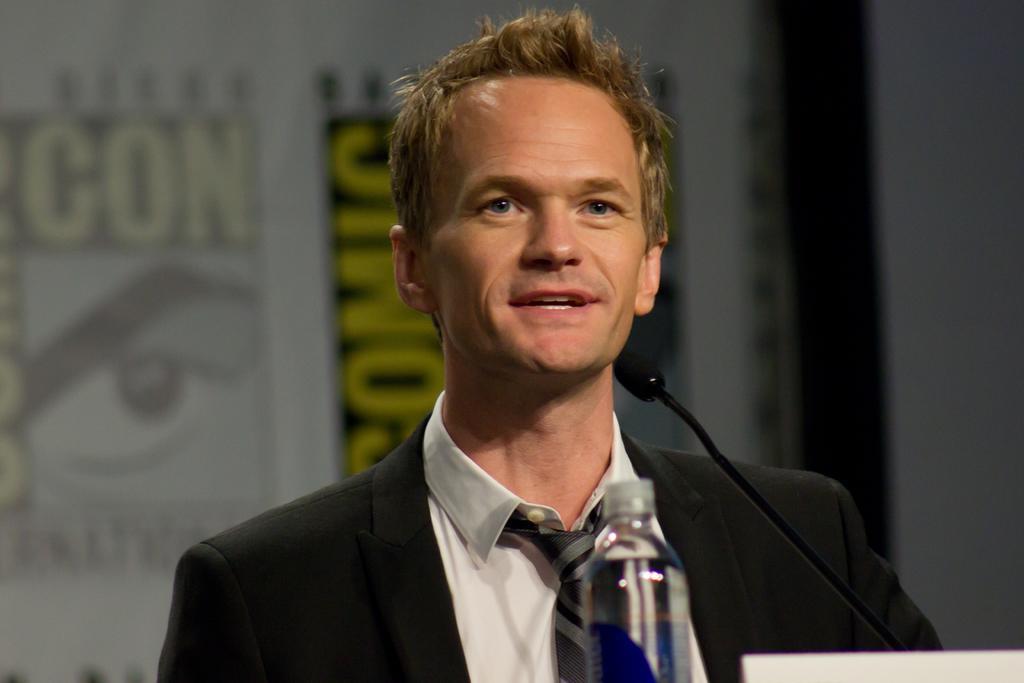Can you describe this image briefly? In this picture there is a man standing and speaking, he has a microphone and a water bottle in front of him. 